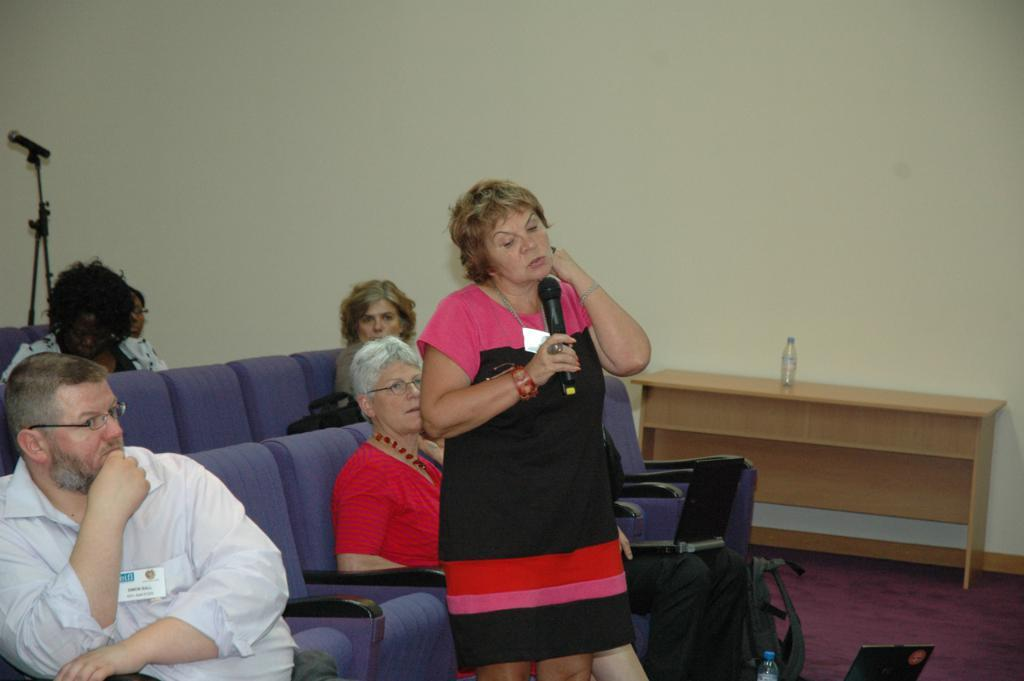Where was the image taken? The image was taken in a room. What can be seen in the foreground of the image? There are people, chairs, a desk, a bottle, a backpack, and a microphone in the foreground of the image. What else can be seen in the foreground of the image? There are other objects in the foreground of the image. How is the background of the image? The background of the image is well-lit. What type of arithmetic problem is being solved by the airplane in the image? There is no airplane present in the image, and therefore no arithmetic problem can be solved by an airplane. What type of crime is the crook committing in the image? There is no crook or crime being committed in the image. 